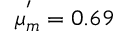Convert formula to latex. <formula><loc_0><loc_0><loc_500><loc_500>\mu _ { m } ^ { ^ { \prime } } = 0 . 6 9</formula> 